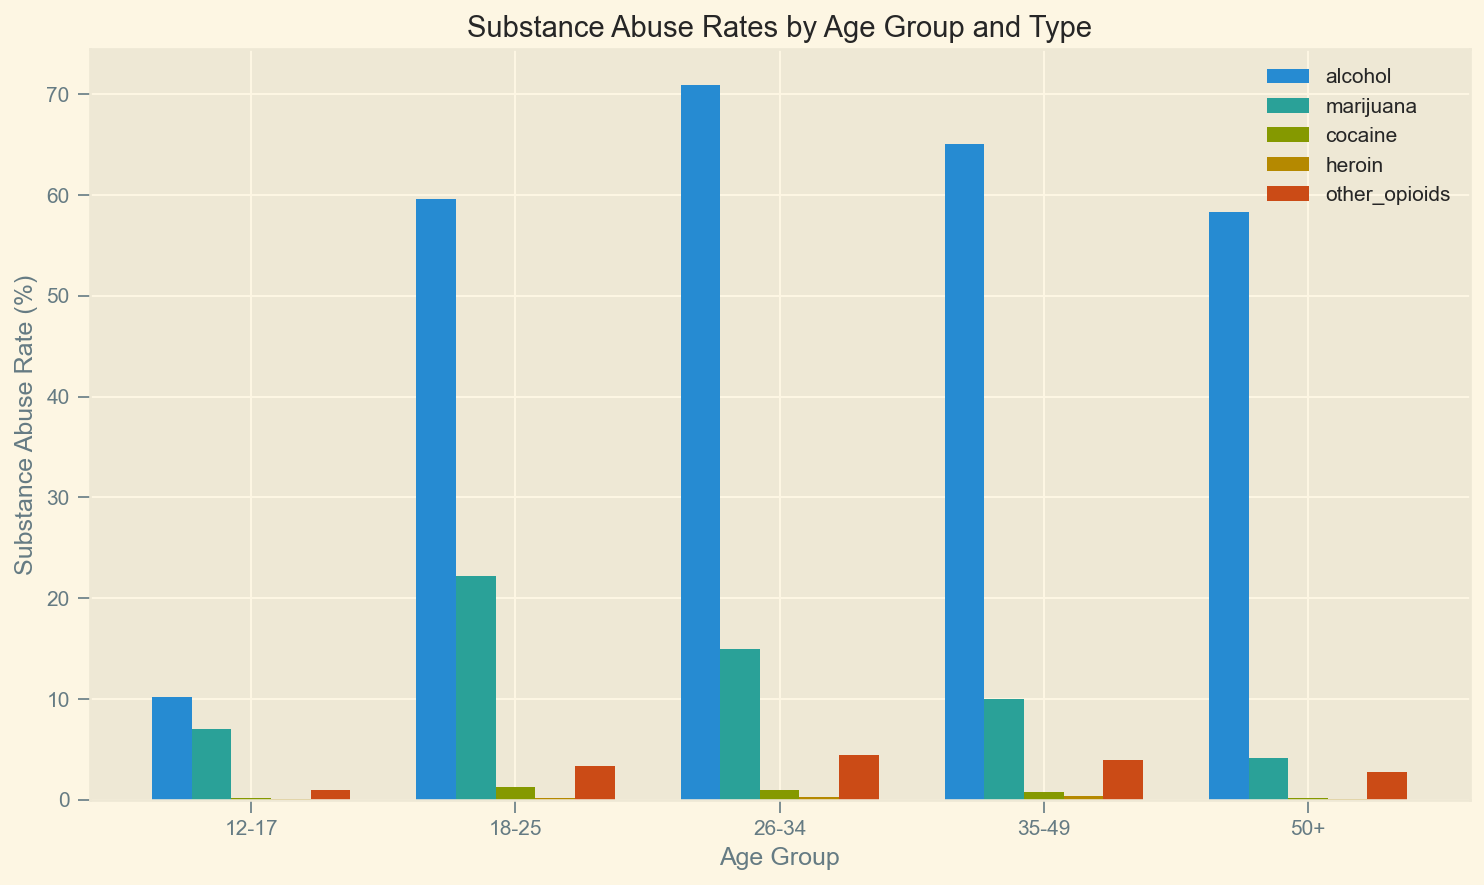What substance has the highest abuse rate in the 18-25 age group? To find the substance with the highest abuse rate in the 18-25 age group, look at the heights of the bars for that age group. The tallest bar represents alcohol.
Answer: Alcohol Which age group shows the lowest percentage of heroin abuse? Check the heights of the heroin bars for all age groups. The 12-17 and 50+ age groups both have very short bars for heroin abuse, both having a rate of 0.1%.
Answer: 12-17 and 50+ Which substance has the smallest difference in abuse rates between the 12-17 and 18-25 age groups? Calculate the difference in abuse rates for each substance between the 12-17 and 18-25 age groups: Alcohol (49.4), Marijuana (15.2), Cocaine (1.1), Heroin (0.1), Other Opioids (2.4). The smallest difference is for Heroin.
Answer: Heroin What is the total abuse rate for marijuana across all age groups? Sum the marijuana abuse rates for all age groups: 7.0 (12-17) + 22.2 (18-25) + 15.0 (26-34) + 10.0 (35-49) + 4.2 (50+). This totals 58.4%.
Answer: 58.4% Which substance shows a noticeable decline in abuse rates after the 26-34 age group? Compare the bar heights for each substance between the 26-34 and 35-49 age groups. Alcohol abuse shows a decline from 70.9% to 65.1%, and Marijuana from 15.0% to 10.0%. Other substances don't show as noticeable changes.
Answer: Alcohol and Marijuana How does the cocaine abuse rate for the 35-49 age group compare to that for the 50+ age group? Look at the heights of the cocaine bars for the 35-49 and 50+ age groups. The rate is 0.8% for 35-49 and 0.2% for 50+. Thus, it's higher in the 35-49 age group.
Answer: 35-49 is higher Among the age groups under consideration, which one shows the highest rate of abuse for other opioids? Identify the tallest bar for other opioids across all age groups. The 26-34 age group has the highest rate at 4.5%.
Answer: 26-34 What is the average abuse rate for alcohol in the 18-25, 26-34, and 35-49 age groups? Calculate the average of the alcohol abuse rates for these age groups: (59.6 + 70.9 + 65.1) / 3 = 65.2%.
Answer: 65.2% What visual trend is noticeable regarding marijuana abuse rates across different age groups? Observe the heights of the marijuana bars across age groups. The rate is highest in the 18-25 age group and generally decreases as age increases.
Answer: Decreases with age In which age group is the bar for alcohol the tallest relative to the bars for other substances? Observe the age groups and identify where the alcohol bar is significantly taller than the other substance bars. The 26-34 age group shows the tallest alcohol bar relative to others.
Answer: 26-34 